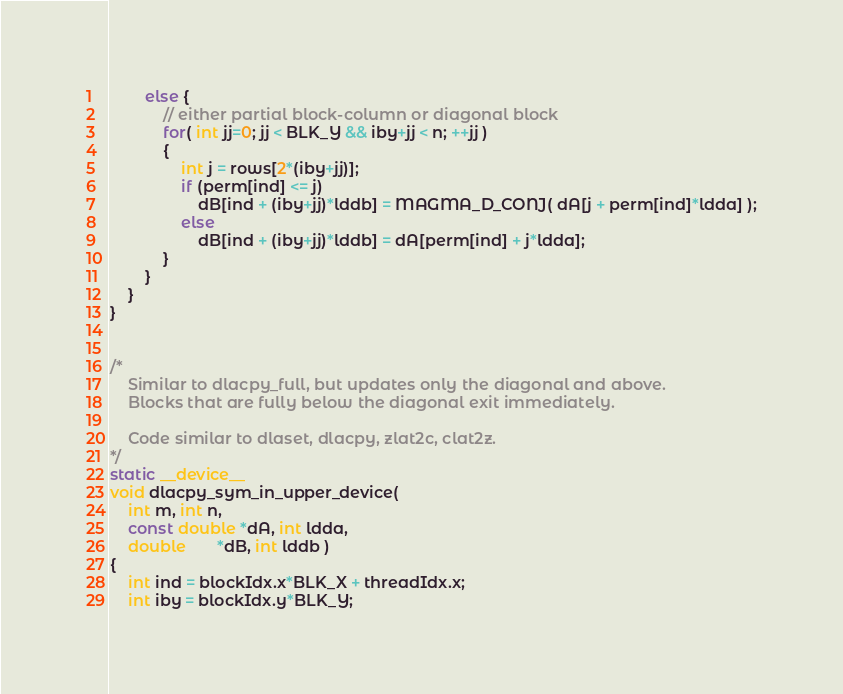Convert code to text. <code><loc_0><loc_0><loc_500><loc_500><_Cuda_>        else {
            // either partial block-column or diagonal block
            for( int jj=0; jj < BLK_Y && iby+jj < n; ++jj ) 
            {
                int j = rows[2*(iby+jj)];
                if (perm[ind] <= j)
                    dB[ind + (iby+jj)*lddb] = MAGMA_D_CONJ( dA[j + perm[ind]*ldda] );
                else
                    dB[ind + (iby+jj)*lddb] = dA[perm[ind] + j*ldda];
            }
        }
    }
}


/*
    Similar to dlacpy_full, but updates only the diagonal and above.
    Blocks that are fully below the diagonal exit immediately.

    Code similar to dlaset, dlacpy, zlat2c, clat2z.
*/
static __device__
void dlacpy_sym_in_upper_device(
    int m, int n,
    const double *dA, int ldda,
    double       *dB, int lddb )
{
    int ind = blockIdx.x*BLK_X + threadIdx.x;
    int iby = blockIdx.y*BLK_Y;</code> 